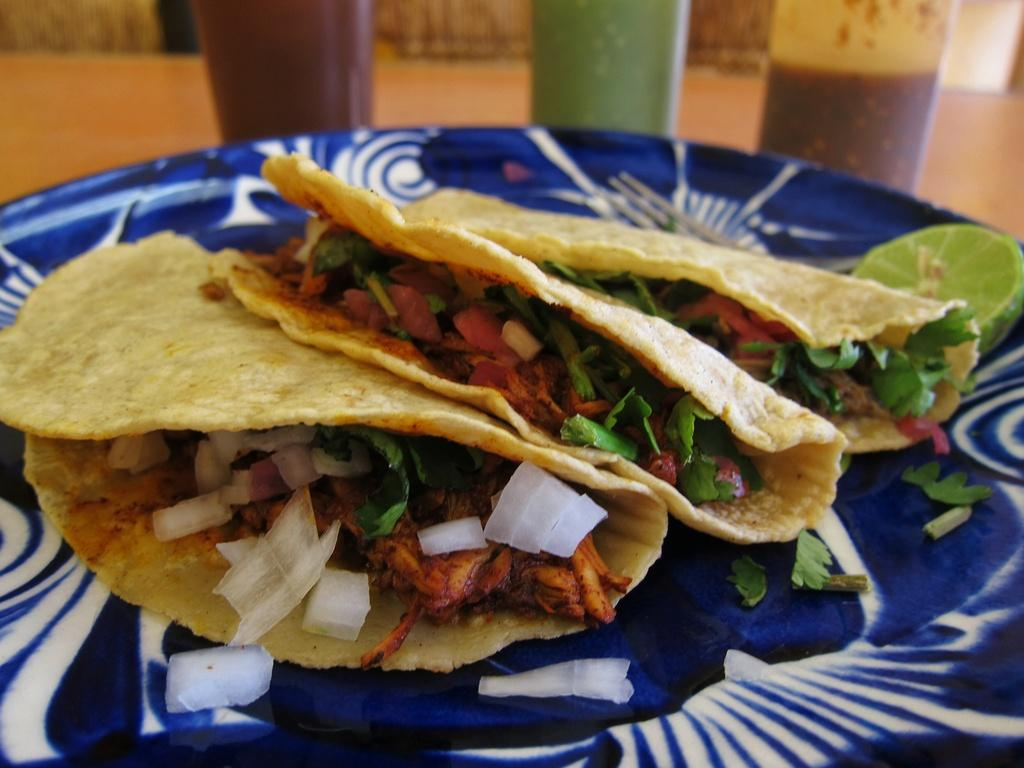What object is present on the table in the image? There is a plate in the image. What is on the plate? There is food on the plate. What else can be seen on the table in the image? There are glasses on the table behind the plate. What type of bread can be seen in the pocket of the person in the image? There is no person or pocket visible in the image, so it is not possible to determine if there is any bread present. 